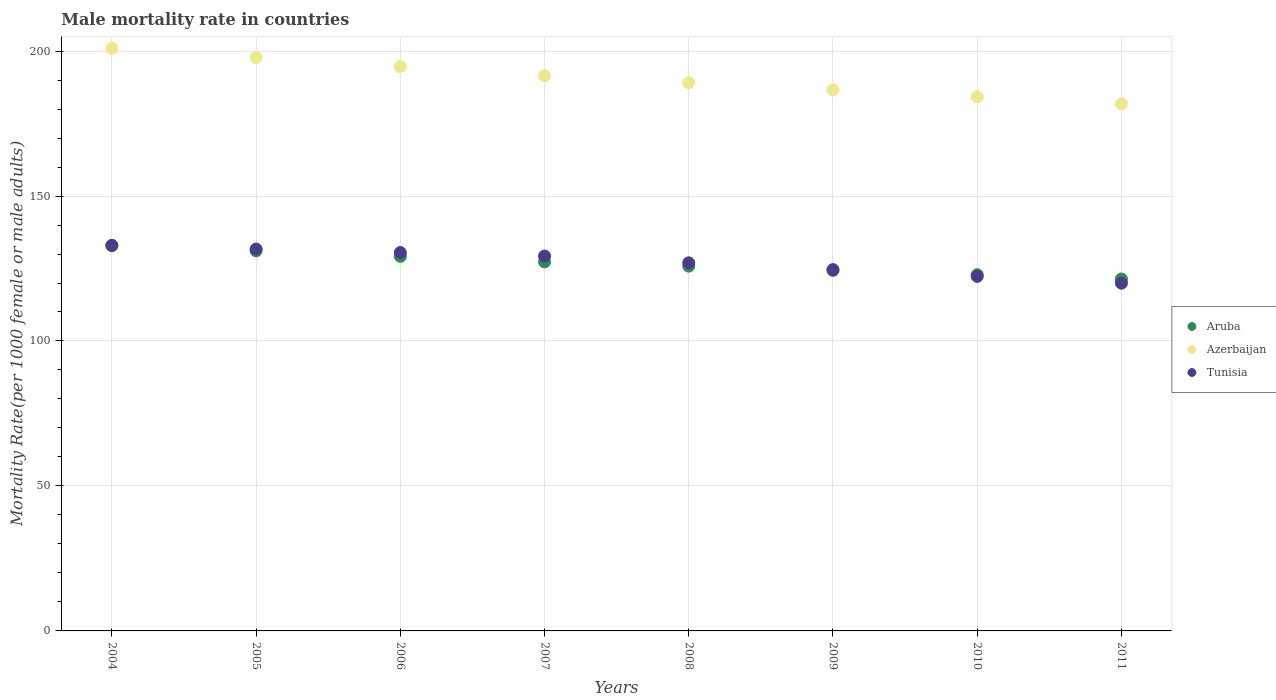Is the number of dotlines equal to the number of legend labels?
Give a very brief answer. Yes. What is the male mortality rate in Tunisia in 2009?
Keep it short and to the point. 124.62. Across all years, what is the maximum male mortality rate in Tunisia?
Your answer should be very brief. 132.93. Across all years, what is the minimum male mortality rate in Tunisia?
Give a very brief answer. 119.94. In which year was the male mortality rate in Aruba maximum?
Your answer should be very brief. 2004. What is the total male mortality rate in Azerbaijan in the graph?
Offer a very short reply. 1526.63. What is the difference between the male mortality rate in Azerbaijan in 2005 and that in 2010?
Ensure brevity in your answer.  13.57. What is the difference between the male mortality rate in Tunisia in 2006 and the male mortality rate in Azerbaijan in 2004?
Ensure brevity in your answer.  -70.43. What is the average male mortality rate in Azerbaijan per year?
Your answer should be compact. 190.83. In the year 2004, what is the difference between the male mortality rate in Tunisia and male mortality rate in Aruba?
Give a very brief answer. -0.06. What is the ratio of the male mortality rate in Azerbaijan in 2008 to that in 2010?
Your answer should be very brief. 1.03. What is the difference between the highest and the second highest male mortality rate in Aruba?
Offer a terse response. 1.9. What is the difference between the highest and the lowest male mortality rate in Tunisia?
Offer a terse response. 12.99. Does the male mortality rate in Aruba monotonically increase over the years?
Offer a very short reply. No. Is the male mortality rate in Azerbaijan strictly greater than the male mortality rate in Aruba over the years?
Give a very brief answer. Yes. How many years are there in the graph?
Provide a succinct answer. 8. Are the values on the major ticks of Y-axis written in scientific E-notation?
Give a very brief answer. No. Does the graph contain any zero values?
Your response must be concise. No. Does the graph contain grids?
Give a very brief answer. Yes. Where does the legend appear in the graph?
Offer a very short reply. Center right. How many legend labels are there?
Ensure brevity in your answer.  3. What is the title of the graph?
Your answer should be compact. Male mortality rate in countries. What is the label or title of the X-axis?
Your answer should be very brief. Years. What is the label or title of the Y-axis?
Make the answer very short. Mortality Rate(per 1000 female or male adults). What is the Mortality Rate(per 1000 female or male adults) of Aruba in 2004?
Give a very brief answer. 132.99. What is the Mortality Rate(per 1000 female or male adults) in Azerbaijan in 2004?
Ensure brevity in your answer.  200.95. What is the Mortality Rate(per 1000 female or male adults) of Tunisia in 2004?
Give a very brief answer. 132.93. What is the Mortality Rate(per 1000 female or male adults) in Aruba in 2005?
Keep it short and to the point. 131.09. What is the Mortality Rate(per 1000 female or male adults) of Azerbaijan in 2005?
Offer a very short reply. 197.8. What is the Mortality Rate(per 1000 female or male adults) in Tunisia in 2005?
Keep it short and to the point. 131.72. What is the Mortality Rate(per 1000 female or male adults) of Aruba in 2006?
Offer a terse response. 129.19. What is the Mortality Rate(per 1000 female or male adults) in Azerbaijan in 2006?
Make the answer very short. 194.65. What is the Mortality Rate(per 1000 female or male adults) in Tunisia in 2006?
Your answer should be compact. 130.51. What is the Mortality Rate(per 1000 female or male adults) in Aruba in 2007?
Provide a short and direct response. 127.29. What is the Mortality Rate(per 1000 female or male adults) in Azerbaijan in 2007?
Your answer should be compact. 191.5. What is the Mortality Rate(per 1000 female or male adults) of Tunisia in 2007?
Provide a succinct answer. 129.3. What is the Mortality Rate(per 1000 female or male adults) in Aruba in 2008?
Ensure brevity in your answer.  125.81. What is the Mortality Rate(per 1000 female or male adults) of Azerbaijan in 2008?
Keep it short and to the point. 189.07. What is the Mortality Rate(per 1000 female or male adults) of Tunisia in 2008?
Offer a terse response. 126.96. What is the Mortality Rate(per 1000 female or male adults) in Aruba in 2009?
Your answer should be compact. 124.33. What is the Mortality Rate(per 1000 female or male adults) in Azerbaijan in 2009?
Your answer should be compact. 186.65. What is the Mortality Rate(per 1000 female or male adults) in Tunisia in 2009?
Provide a succinct answer. 124.62. What is the Mortality Rate(per 1000 female or male adults) in Aruba in 2010?
Provide a succinct answer. 122.86. What is the Mortality Rate(per 1000 female or male adults) in Azerbaijan in 2010?
Give a very brief answer. 184.22. What is the Mortality Rate(per 1000 female or male adults) of Tunisia in 2010?
Make the answer very short. 122.28. What is the Mortality Rate(per 1000 female or male adults) of Aruba in 2011?
Ensure brevity in your answer.  121.38. What is the Mortality Rate(per 1000 female or male adults) of Azerbaijan in 2011?
Offer a very short reply. 181.8. What is the Mortality Rate(per 1000 female or male adults) of Tunisia in 2011?
Keep it short and to the point. 119.94. Across all years, what is the maximum Mortality Rate(per 1000 female or male adults) of Aruba?
Offer a very short reply. 132.99. Across all years, what is the maximum Mortality Rate(per 1000 female or male adults) of Azerbaijan?
Make the answer very short. 200.95. Across all years, what is the maximum Mortality Rate(per 1000 female or male adults) of Tunisia?
Provide a succinct answer. 132.93. Across all years, what is the minimum Mortality Rate(per 1000 female or male adults) of Aruba?
Your response must be concise. 121.38. Across all years, what is the minimum Mortality Rate(per 1000 female or male adults) in Azerbaijan?
Your answer should be compact. 181.8. Across all years, what is the minimum Mortality Rate(per 1000 female or male adults) of Tunisia?
Give a very brief answer. 119.94. What is the total Mortality Rate(per 1000 female or male adults) in Aruba in the graph?
Give a very brief answer. 1014.94. What is the total Mortality Rate(per 1000 female or male adults) in Azerbaijan in the graph?
Offer a very short reply. 1526.63. What is the total Mortality Rate(per 1000 female or male adults) of Tunisia in the graph?
Give a very brief answer. 1018.26. What is the difference between the Mortality Rate(per 1000 female or male adults) of Aruba in 2004 and that in 2005?
Your response must be concise. 1.9. What is the difference between the Mortality Rate(per 1000 female or male adults) of Azerbaijan in 2004 and that in 2005?
Your answer should be compact. 3.15. What is the difference between the Mortality Rate(per 1000 female or male adults) of Tunisia in 2004 and that in 2005?
Your answer should be very brief. 1.21. What is the difference between the Mortality Rate(per 1000 female or male adults) of Aruba in 2004 and that in 2006?
Give a very brief answer. 3.8. What is the difference between the Mortality Rate(per 1000 female or male adults) of Azerbaijan in 2004 and that in 2006?
Your answer should be very brief. 6.3. What is the difference between the Mortality Rate(per 1000 female or male adults) of Tunisia in 2004 and that in 2006?
Ensure brevity in your answer.  2.42. What is the difference between the Mortality Rate(per 1000 female or male adults) of Aruba in 2004 and that in 2007?
Keep it short and to the point. 5.7. What is the difference between the Mortality Rate(per 1000 female or male adults) of Azerbaijan in 2004 and that in 2007?
Your answer should be compact. 9.45. What is the difference between the Mortality Rate(per 1000 female or male adults) of Tunisia in 2004 and that in 2007?
Offer a terse response. 3.62. What is the difference between the Mortality Rate(per 1000 female or male adults) in Aruba in 2004 and that in 2008?
Provide a succinct answer. 7.18. What is the difference between the Mortality Rate(per 1000 female or male adults) in Azerbaijan in 2004 and that in 2008?
Offer a very short reply. 11.87. What is the difference between the Mortality Rate(per 1000 female or male adults) in Tunisia in 2004 and that in 2008?
Provide a succinct answer. 5.96. What is the difference between the Mortality Rate(per 1000 female or male adults) of Aruba in 2004 and that in 2009?
Your answer should be very brief. 8.65. What is the difference between the Mortality Rate(per 1000 female or male adults) of Azerbaijan in 2004 and that in 2009?
Provide a short and direct response. 14.3. What is the difference between the Mortality Rate(per 1000 female or male adults) of Tunisia in 2004 and that in 2009?
Your answer should be compact. 8.31. What is the difference between the Mortality Rate(per 1000 female or male adults) of Aruba in 2004 and that in 2010?
Offer a very short reply. 10.13. What is the difference between the Mortality Rate(per 1000 female or male adults) of Azerbaijan in 2004 and that in 2010?
Provide a short and direct response. 16.72. What is the difference between the Mortality Rate(per 1000 female or male adults) of Tunisia in 2004 and that in 2010?
Provide a succinct answer. 10.65. What is the difference between the Mortality Rate(per 1000 female or male adults) of Aruba in 2004 and that in 2011?
Offer a terse response. 11.61. What is the difference between the Mortality Rate(per 1000 female or male adults) in Azerbaijan in 2004 and that in 2011?
Your response must be concise. 19.15. What is the difference between the Mortality Rate(per 1000 female or male adults) of Tunisia in 2004 and that in 2011?
Your answer should be very brief. 12.99. What is the difference between the Mortality Rate(per 1000 female or male adults) of Aruba in 2005 and that in 2006?
Give a very brief answer. 1.9. What is the difference between the Mortality Rate(per 1000 female or male adults) in Azerbaijan in 2005 and that in 2006?
Offer a terse response. 3.15. What is the difference between the Mortality Rate(per 1000 female or male adults) in Tunisia in 2005 and that in 2006?
Give a very brief answer. 1.21. What is the difference between the Mortality Rate(per 1000 female or male adults) of Aruba in 2005 and that in 2007?
Offer a very short reply. 3.8. What is the difference between the Mortality Rate(per 1000 female or male adults) in Azerbaijan in 2005 and that in 2007?
Your answer should be very brief. 6.3. What is the difference between the Mortality Rate(per 1000 female or male adults) in Tunisia in 2005 and that in 2007?
Make the answer very short. 2.42. What is the difference between the Mortality Rate(per 1000 female or male adults) of Aruba in 2005 and that in 2008?
Your answer should be very brief. 5.28. What is the difference between the Mortality Rate(per 1000 female or male adults) in Azerbaijan in 2005 and that in 2008?
Ensure brevity in your answer.  8.72. What is the difference between the Mortality Rate(per 1000 female or male adults) in Tunisia in 2005 and that in 2008?
Give a very brief answer. 4.76. What is the difference between the Mortality Rate(per 1000 female or male adults) of Aruba in 2005 and that in 2009?
Your answer should be compact. 6.75. What is the difference between the Mortality Rate(per 1000 female or male adults) of Azerbaijan in 2005 and that in 2009?
Keep it short and to the point. 11.15. What is the difference between the Mortality Rate(per 1000 female or male adults) in Tunisia in 2005 and that in 2009?
Make the answer very short. 7.1. What is the difference between the Mortality Rate(per 1000 female or male adults) in Aruba in 2005 and that in 2010?
Your answer should be very brief. 8.23. What is the difference between the Mortality Rate(per 1000 female or male adults) in Azerbaijan in 2005 and that in 2010?
Your answer should be compact. 13.57. What is the difference between the Mortality Rate(per 1000 female or male adults) in Tunisia in 2005 and that in 2010?
Offer a terse response. 9.44. What is the difference between the Mortality Rate(per 1000 female or male adults) of Aruba in 2005 and that in 2011?
Provide a short and direct response. 9.71. What is the difference between the Mortality Rate(per 1000 female or male adults) of Azerbaijan in 2005 and that in 2011?
Make the answer very short. 16. What is the difference between the Mortality Rate(per 1000 female or male adults) of Tunisia in 2005 and that in 2011?
Give a very brief answer. 11.78. What is the difference between the Mortality Rate(per 1000 female or male adults) in Aruba in 2006 and that in 2007?
Provide a short and direct response. 1.9. What is the difference between the Mortality Rate(per 1000 female or male adults) of Azerbaijan in 2006 and that in 2007?
Keep it short and to the point. 3.15. What is the difference between the Mortality Rate(per 1000 female or male adults) of Tunisia in 2006 and that in 2007?
Make the answer very short. 1.21. What is the difference between the Mortality Rate(per 1000 female or male adults) of Aruba in 2006 and that in 2008?
Give a very brief answer. 3.38. What is the difference between the Mortality Rate(per 1000 female or male adults) of Azerbaijan in 2006 and that in 2008?
Give a very brief answer. 5.57. What is the difference between the Mortality Rate(per 1000 female or male adults) in Tunisia in 2006 and that in 2008?
Your answer should be very brief. 3.55. What is the difference between the Mortality Rate(per 1000 female or male adults) in Aruba in 2006 and that in 2009?
Give a very brief answer. 4.85. What is the difference between the Mortality Rate(per 1000 female or male adults) of Azerbaijan in 2006 and that in 2009?
Your response must be concise. 8. What is the difference between the Mortality Rate(per 1000 female or male adults) of Tunisia in 2006 and that in 2009?
Offer a very short reply. 5.89. What is the difference between the Mortality Rate(per 1000 female or male adults) of Aruba in 2006 and that in 2010?
Ensure brevity in your answer.  6.33. What is the difference between the Mortality Rate(per 1000 female or male adults) in Azerbaijan in 2006 and that in 2010?
Offer a very short reply. 10.42. What is the difference between the Mortality Rate(per 1000 female or male adults) in Tunisia in 2006 and that in 2010?
Make the answer very short. 8.23. What is the difference between the Mortality Rate(per 1000 female or male adults) of Aruba in 2006 and that in 2011?
Your response must be concise. 7.8. What is the difference between the Mortality Rate(per 1000 female or male adults) of Azerbaijan in 2006 and that in 2011?
Give a very brief answer. 12.85. What is the difference between the Mortality Rate(per 1000 female or male adults) of Tunisia in 2006 and that in 2011?
Offer a very short reply. 10.57. What is the difference between the Mortality Rate(per 1000 female or male adults) of Aruba in 2007 and that in 2008?
Provide a short and direct response. 1.48. What is the difference between the Mortality Rate(per 1000 female or male adults) in Azerbaijan in 2007 and that in 2008?
Keep it short and to the point. 2.43. What is the difference between the Mortality Rate(per 1000 female or male adults) in Tunisia in 2007 and that in 2008?
Your answer should be compact. 2.34. What is the difference between the Mortality Rate(per 1000 female or male adults) in Aruba in 2007 and that in 2009?
Give a very brief answer. 2.95. What is the difference between the Mortality Rate(per 1000 female or male adults) of Azerbaijan in 2007 and that in 2009?
Ensure brevity in your answer.  4.85. What is the difference between the Mortality Rate(per 1000 female or male adults) of Tunisia in 2007 and that in 2009?
Your answer should be very brief. 4.68. What is the difference between the Mortality Rate(per 1000 female or male adults) in Aruba in 2007 and that in 2010?
Provide a succinct answer. 4.43. What is the difference between the Mortality Rate(per 1000 female or male adults) in Azerbaijan in 2007 and that in 2010?
Your answer should be very brief. 7.28. What is the difference between the Mortality Rate(per 1000 female or male adults) of Tunisia in 2007 and that in 2010?
Offer a terse response. 7.02. What is the difference between the Mortality Rate(per 1000 female or male adults) of Aruba in 2007 and that in 2011?
Make the answer very short. 5.9. What is the difference between the Mortality Rate(per 1000 female or male adults) in Azerbaijan in 2007 and that in 2011?
Make the answer very short. 9.7. What is the difference between the Mortality Rate(per 1000 female or male adults) of Tunisia in 2007 and that in 2011?
Keep it short and to the point. 9.37. What is the difference between the Mortality Rate(per 1000 female or male adults) of Aruba in 2008 and that in 2009?
Ensure brevity in your answer.  1.48. What is the difference between the Mortality Rate(per 1000 female or male adults) in Azerbaijan in 2008 and that in 2009?
Offer a very short reply. 2.43. What is the difference between the Mortality Rate(per 1000 female or male adults) of Tunisia in 2008 and that in 2009?
Provide a short and direct response. 2.34. What is the difference between the Mortality Rate(per 1000 female or male adults) in Aruba in 2008 and that in 2010?
Your answer should be very brief. 2.95. What is the difference between the Mortality Rate(per 1000 female or male adults) in Azerbaijan in 2008 and that in 2010?
Your answer should be very brief. 4.85. What is the difference between the Mortality Rate(per 1000 female or male adults) in Tunisia in 2008 and that in 2010?
Your answer should be very brief. 4.68. What is the difference between the Mortality Rate(per 1000 female or male adults) in Aruba in 2008 and that in 2011?
Your response must be concise. 4.43. What is the difference between the Mortality Rate(per 1000 female or male adults) of Azerbaijan in 2008 and that in 2011?
Keep it short and to the point. 7.28. What is the difference between the Mortality Rate(per 1000 female or male adults) in Tunisia in 2008 and that in 2011?
Offer a terse response. 7.02. What is the difference between the Mortality Rate(per 1000 female or male adults) in Aruba in 2009 and that in 2010?
Give a very brief answer. 1.48. What is the difference between the Mortality Rate(per 1000 female or male adults) of Azerbaijan in 2009 and that in 2010?
Offer a very short reply. 2.43. What is the difference between the Mortality Rate(per 1000 female or male adults) in Tunisia in 2009 and that in 2010?
Offer a very short reply. 2.34. What is the difference between the Mortality Rate(per 1000 female or male adults) of Aruba in 2009 and that in 2011?
Give a very brief answer. 2.95. What is the difference between the Mortality Rate(per 1000 female or male adults) in Azerbaijan in 2009 and that in 2011?
Your response must be concise. 4.85. What is the difference between the Mortality Rate(per 1000 female or male adults) of Tunisia in 2009 and that in 2011?
Give a very brief answer. 4.68. What is the difference between the Mortality Rate(per 1000 female or male adults) in Aruba in 2010 and that in 2011?
Provide a succinct answer. 1.48. What is the difference between the Mortality Rate(per 1000 female or male adults) of Azerbaijan in 2010 and that in 2011?
Your answer should be very brief. 2.43. What is the difference between the Mortality Rate(per 1000 female or male adults) in Tunisia in 2010 and that in 2011?
Your response must be concise. 2.34. What is the difference between the Mortality Rate(per 1000 female or male adults) of Aruba in 2004 and the Mortality Rate(per 1000 female or male adults) of Azerbaijan in 2005?
Provide a short and direct response. -64.81. What is the difference between the Mortality Rate(per 1000 female or male adults) of Aruba in 2004 and the Mortality Rate(per 1000 female or male adults) of Tunisia in 2005?
Keep it short and to the point. 1.27. What is the difference between the Mortality Rate(per 1000 female or male adults) in Azerbaijan in 2004 and the Mortality Rate(per 1000 female or male adults) in Tunisia in 2005?
Give a very brief answer. 69.23. What is the difference between the Mortality Rate(per 1000 female or male adults) in Aruba in 2004 and the Mortality Rate(per 1000 female or male adults) in Azerbaijan in 2006?
Make the answer very short. -61.66. What is the difference between the Mortality Rate(per 1000 female or male adults) of Aruba in 2004 and the Mortality Rate(per 1000 female or male adults) of Tunisia in 2006?
Make the answer very short. 2.48. What is the difference between the Mortality Rate(per 1000 female or male adults) in Azerbaijan in 2004 and the Mortality Rate(per 1000 female or male adults) in Tunisia in 2006?
Your response must be concise. 70.43. What is the difference between the Mortality Rate(per 1000 female or male adults) in Aruba in 2004 and the Mortality Rate(per 1000 female or male adults) in Azerbaijan in 2007?
Keep it short and to the point. -58.51. What is the difference between the Mortality Rate(per 1000 female or male adults) of Aruba in 2004 and the Mortality Rate(per 1000 female or male adults) of Tunisia in 2007?
Your answer should be very brief. 3.69. What is the difference between the Mortality Rate(per 1000 female or male adults) in Azerbaijan in 2004 and the Mortality Rate(per 1000 female or male adults) in Tunisia in 2007?
Make the answer very short. 71.64. What is the difference between the Mortality Rate(per 1000 female or male adults) of Aruba in 2004 and the Mortality Rate(per 1000 female or male adults) of Azerbaijan in 2008?
Give a very brief answer. -56.08. What is the difference between the Mortality Rate(per 1000 female or male adults) of Aruba in 2004 and the Mortality Rate(per 1000 female or male adults) of Tunisia in 2008?
Provide a succinct answer. 6.03. What is the difference between the Mortality Rate(per 1000 female or male adults) in Azerbaijan in 2004 and the Mortality Rate(per 1000 female or male adults) in Tunisia in 2008?
Your response must be concise. 73.98. What is the difference between the Mortality Rate(per 1000 female or male adults) in Aruba in 2004 and the Mortality Rate(per 1000 female or male adults) in Azerbaijan in 2009?
Give a very brief answer. -53.66. What is the difference between the Mortality Rate(per 1000 female or male adults) in Aruba in 2004 and the Mortality Rate(per 1000 female or male adults) in Tunisia in 2009?
Offer a very short reply. 8.37. What is the difference between the Mortality Rate(per 1000 female or male adults) in Azerbaijan in 2004 and the Mortality Rate(per 1000 female or male adults) in Tunisia in 2009?
Provide a succinct answer. 76.33. What is the difference between the Mortality Rate(per 1000 female or male adults) in Aruba in 2004 and the Mortality Rate(per 1000 female or male adults) in Azerbaijan in 2010?
Make the answer very short. -51.23. What is the difference between the Mortality Rate(per 1000 female or male adults) of Aruba in 2004 and the Mortality Rate(per 1000 female or male adults) of Tunisia in 2010?
Provide a succinct answer. 10.71. What is the difference between the Mortality Rate(per 1000 female or male adults) of Azerbaijan in 2004 and the Mortality Rate(per 1000 female or male adults) of Tunisia in 2010?
Your answer should be very brief. 78.67. What is the difference between the Mortality Rate(per 1000 female or male adults) of Aruba in 2004 and the Mortality Rate(per 1000 female or male adults) of Azerbaijan in 2011?
Give a very brief answer. -48.81. What is the difference between the Mortality Rate(per 1000 female or male adults) in Aruba in 2004 and the Mortality Rate(per 1000 female or male adults) in Tunisia in 2011?
Your answer should be very brief. 13.05. What is the difference between the Mortality Rate(per 1000 female or male adults) in Azerbaijan in 2004 and the Mortality Rate(per 1000 female or male adults) in Tunisia in 2011?
Your answer should be compact. 81.01. What is the difference between the Mortality Rate(per 1000 female or male adults) of Aruba in 2005 and the Mortality Rate(per 1000 female or male adults) of Azerbaijan in 2006?
Keep it short and to the point. -63.56. What is the difference between the Mortality Rate(per 1000 female or male adults) of Aruba in 2005 and the Mortality Rate(per 1000 female or male adults) of Tunisia in 2006?
Offer a very short reply. 0.58. What is the difference between the Mortality Rate(per 1000 female or male adults) in Azerbaijan in 2005 and the Mortality Rate(per 1000 female or male adults) in Tunisia in 2006?
Ensure brevity in your answer.  67.29. What is the difference between the Mortality Rate(per 1000 female or male adults) in Aruba in 2005 and the Mortality Rate(per 1000 female or male adults) in Azerbaijan in 2007?
Provide a succinct answer. -60.41. What is the difference between the Mortality Rate(per 1000 female or male adults) in Aruba in 2005 and the Mortality Rate(per 1000 female or male adults) in Tunisia in 2007?
Your answer should be very brief. 1.78. What is the difference between the Mortality Rate(per 1000 female or male adults) of Azerbaijan in 2005 and the Mortality Rate(per 1000 female or male adults) of Tunisia in 2007?
Ensure brevity in your answer.  68.49. What is the difference between the Mortality Rate(per 1000 female or male adults) of Aruba in 2005 and the Mortality Rate(per 1000 female or male adults) of Azerbaijan in 2008?
Your answer should be compact. -57.98. What is the difference between the Mortality Rate(per 1000 female or male adults) in Aruba in 2005 and the Mortality Rate(per 1000 female or male adults) in Tunisia in 2008?
Your response must be concise. 4.13. What is the difference between the Mortality Rate(per 1000 female or male adults) of Azerbaijan in 2005 and the Mortality Rate(per 1000 female or male adults) of Tunisia in 2008?
Give a very brief answer. 70.83. What is the difference between the Mortality Rate(per 1000 female or male adults) of Aruba in 2005 and the Mortality Rate(per 1000 female or male adults) of Azerbaijan in 2009?
Your answer should be compact. -55.56. What is the difference between the Mortality Rate(per 1000 female or male adults) of Aruba in 2005 and the Mortality Rate(per 1000 female or male adults) of Tunisia in 2009?
Make the answer very short. 6.47. What is the difference between the Mortality Rate(per 1000 female or male adults) in Azerbaijan in 2005 and the Mortality Rate(per 1000 female or male adults) in Tunisia in 2009?
Provide a short and direct response. 73.18. What is the difference between the Mortality Rate(per 1000 female or male adults) of Aruba in 2005 and the Mortality Rate(per 1000 female or male adults) of Azerbaijan in 2010?
Make the answer very short. -53.13. What is the difference between the Mortality Rate(per 1000 female or male adults) in Aruba in 2005 and the Mortality Rate(per 1000 female or male adults) in Tunisia in 2010?
Your answer should be very brief. 8.81. What is the difference between the Mortality Rate(per 1000 female or male adults) in Azerbaijan in 2005 and the Mortality Rate(per 1000 female or male adults) in Tunisia in 2010?
Provide a succinct answer. 75.52. What is the difference between the Mortality Rate(per 1000 female or male adults) in Aruba in 2005 and the Mortality Rate(per 1000 female or male adults) in Azerbaijan in 2011?
Your response must be concise. -50.71. What is the difference between the Mortality Rate(per 1000 female or male adults) of Aruba in 2005 and the Mortality Rate(per 1000 female or male adults) of Tunisia in 2011?
Offer a terse response. 11.15. What is the difference between the Mortality Rate(per 1000 female or male adults) in Azerbaijan in 2005 and the Mortality Rate(per 1000 female or male adults) in Tunisia in 2011?
Give a very brief answer. 77.86. What is the difference between the Mortality Rate(per 1000 female or male adults) in Aruba in 2006 and the Mortality Rate(per 1000 female or male adults) in Azerbaijan in 2007?
Offer a terse response. -62.31. What is the difference between the Mortality Rate(per 1000 female or male adults) in Aruba in 2006 and the Mortality Rate(per 1000 female or male adults) in Tunisia in 2007?
Provide a succinct answer. -0.12. What is the difference between the Mortality Rate(per 1000 female or male adults) in Azerbaijan in 2006 and the Mortality Rate(per 1000 female or male adults) in Tunisia in 2007?
Your answer should be very brief. 65.34. What is the difference between the Mortality Rate(per 1000 female or male adults) in Aruba in 2006 and the Mortality Rate(per 1000 female or male adults) in Azerbaijan in 2008?
Offer a very short reply. -59.88. What is the difference between the Mortality Rate(per 1000 female or male adults) of Aruba in 2006 and the Mortality Rate(per 1000 female or male adults) of Tunisia in 2008?
Give a very brief answer. 2.23. What is the difference between the Mortality Rate(per 1000 female or male adults) of Azerbaijan in 2006 and the Mortality Rate(per 1000 female or male adults) of Tunisia in 2008?
Keep it short and to the point. 67.69. What is the difference between the Mortality Rate(per 1000 female or male adults) of Aruba in 2006 and the Mortality Rate(per 1000 female or male adults) of Azerbaijan in 2009?
Offer a terse response. -57.46. What is the difference between the Mortality Rate(per 1000 female or male adults) of Aruba in 2006 and the Mortality Rate(per 1000 female or male adults) of Tunisia in 2009?
Make the answer very short. 4.57. What is the difference between the Mortality Rate(per 1000 female or male adults) of Azerbaijan in 2006 and the Mortality Rate(per 1000 female or male adults) of Tunisia in 2009?
Your answer should be very brief. 70.03. What is the difference between the Mortality Rate(per 1000 female or male adults) in Aruba in 2006 and the Mortality Rate(per 1000 female or male adults) in Azerbaijan in 2010?
Provide a succinct answer. -55.03. What is the difference between the Mortality Rate(per 1000 female or male adults) in Aruba in 2006 and the Mortality Rate(per 1000 female or male adults) in Tunisia in 2010?
Make the answer very short. 6.91. What is the difference between the Mortality Rate(per 1000 female or male adults) in Azerbaijan in 2006 and the Mortality Rate(per 1000 female or male adults) in Tunisia in 2010?
Your answer should be compact. 72.37. What is the difference between the Mortality Rate(per 1000 female or male adults) of Aruba in 2006 and the Mortality Rate(per 1000 female or male adults) of Azerbaijan in 2011?
Make the answer very short. -52.61. What is the difference between the Mortality Rate(per 1000 female or male adults) of Aruba in 2006 and the Mortality Rate(per 1000 female or male adults) of Tunisia in 2011?
Give a very brief answer. 9.25. What is the difference between the Mortality Rate(per 1000 female or male adults) in Azerbaijan in 2006 and the Mortality Rate(per 1000 female or male adults) in Tunisia in 2011?
Your answer should be compact. 74.71. What is the difference between the Mortality Rate(per 1000 female or male adults) in Aruba in 2007 and the Mortality Rate(per 1000 female or male adults) in Azerbaijan in 2008?
Ensure brevity in your answer.  -61.79. What is the difference between the Mortality Rate(per 1000 female or male adults) of Aruba in 2007 and the Mortality Rate(per 1000 female or male adults) of Tunisia in 2008?
Your answer should be very brief. 0.33. What is the difference between the Mortality Rate(per 1000 female or male adults) of Azerbaijan in 2007 and the Mortality Rate(per 1000 female or male adults) of Tunisia in 2008?
Your answer should be compact. 64.54. What is the difference between the Mortality Rate(per 1000 female or male adults) of Aruba in 2007 and the Mortality Rate(per 1000 female or male adults) of Azerbaijan in 2009?
Your answer should be compact. -59.36. What is the difference between the Mortality Rate(per 1000 female or male adults) in Aruba in 2007 and the Mortality Rate(per 1000 female or male adults) in Tunisia in 2009?
Keep it short and to the point. 2.67. What is the difference between the Mortality Rate(per 1000 female or male adults) in Azerbaijan in 2007 and the Mortality Rate(per 1000 female or male adults) in Tunisia in 2009?
Your response must be concise. 66.88. What is the difference between the Mortality Rate(per 1000 female or male adults) of Aruba in 2007 and the Mortality Rate(per 1000 female or male adults) of Azerbaijan in 2010?
Give a very brief answer. -56.94. What is the difference between the Mortality Rate(per 1000 female or male adults) in Aruba in 2007 and the Mortality Rate(per 1000 female or male adults) in Tunisia in 2010?
Your answer should be very brief. 5.01. What is the difference between the Mortality Rate(per 1000 female or male adults) in Azerbaijan in 2007 and the Mortality Rate(per 1000 female or male adults) in Tunisia in 2010?
Offer a terse response. 69.22. What is the difference between the Mortality Rate(per 1000 female or male adults) of Aruba in 2007 and the Mortality Rate(per 1000 female or male adults) of Azerbaijan in 2011?
Provide a short and direct response. -54.51. What is the difference between the Mortality Rate(per 1000 female or male adults) in Aruba in 2007 and the Mortality Rate(per 1000 female or male adults) in Tunisia in 2011?
Your response must be concise. 7.35. What is the difference between the Mortality Rate(per 1000 female or male adults) in Azerbaijan in 2007 and the Mortality Rate(per 1000 female or male adults) in Tunisia in 2011?
Ensure brevity in your answer.  71.56. What is the difference between the Mortality Rate(per 1000 female or male adults) of Aruba in 2008 and the Mortality Rate(per 1000 female or male adults) of Azerbaijan in 2009?
Ensure brevity in your answer.  -60.84. What is the difference between the Mortality Rate(per 1000 female or male adults) in Aruba in 2008 and the Mortality Rate(per 1000 female or male adults) in Tunisia in 2009?
Your response must be concise. 1.19. What is the difference between the Mortality Rate(per 1000 female or male adults) in Azerbaijan in 2008 and the Mortality Rate(per 1000 female or male adults) in Tunisia in 2009?
Your answer should be compact. 64.45. What is the difference between the Mortality Rate(per 1000 female or male adults) in Aruba in 2008 and the Mortality Rate(per 1000 female or male adults) in Azerbaijan in 2010?
Your response must be concise. -58.41. What is the difference between the Mortality Rate(per 1000 female or male adults) of Aruba in 2008 and the Mortality Rate(per 1000 female or male adults) of Tunisia in 2010?
Provide a succinct answer. 3.53. What is the difference between the Mortality Rate(per 1000 female or male adults) of Azerbaijan in 2008 and the Mortality Rate(per 1000 female or male adults) of Tunisia in 2010?
Give a very brief answer. 66.79. What is the difference between the Mortality Rate(per 1000 female or male adults) of Aruba in 2008 and the Mortality Rate(per 1000 female or male adults) of Azerbaijan in 2011?
Your answer should be very brief. -55.99. What is the difference between the Mortality Rate(per 1000 female or male adults) of Aruba in 2008 and the Mortality Rate(per 1000 female or male adults) of Tunisia in 2011?
Make the answer very short. 5.87. What is the difference between the Mortality Rate(per 1000 female or male adults) of Azerbaijan in 2008 and the Mortality Rate(per 1000 female or male adults) of Tunisia in 2011?
Provide a short and direct response. 69.14. What is the difference between the Mortality Rate(per 1000 female or male adults) in Aruba in 2009 and the Mortality Rate(per 1000 female or male adults) in Azerbaijan in 2010?
Keep it short and to the point. -59.89. What is the difference between the Mortality Rate(per 1000 female or male adults) in Aruba in 2009 and the Mortality Rate(per 1000 female or male adults) in Tunisia in 2010?
Give a very brief answer. 2.06. What is the difference between the Mortality Rate(per 1000 female or male adults) of Azerbaijan in 2009 and the Mortality Rate(per 1000 female or male adults) of Tunisia in 2010?
Offer a terse response. 64.37. What is the difference between the Mortality Rate(per 1000 female or male adults) in Aruba in 2009 and the Mortality Rate(per 1000 female or male adults) in Azerbaijan in 2011?
Provide a short and direct response. -57.46. What is the difference between the Mortality Rate(per 1000 female or male adults) of Aruba in 2009 and the Mortality Rate(per 1000 female or male adults) of Tunisia in 2011?
Your response must be concise. 4.4. What is the difference between the Mortality Rate(per 1000 female or male adults) of Azerbaijan in 2009 and the Mortality Rate(per 1000 female or male adults) of Tunisia in 2011?
Provide a short and direct response. 66.71. What is the difference between the Mortality Rate(per 1000 female or male adults) in Aruba in 2010 and the Mortality Rate(per 1000 female or male adults) in Azerbaijan in 2011?
Your answer should be very brief. -58.94. What is the difference between the Mortality Rate(per 1000 female or male adults) in Aruba in 2010 and the Mortality Rate(per 1000 female or male adults) in Tunisia in 2011?
Keep it short and to the point. 2.92. What is the difference between the Mortality Rate(per 1000 female or male adults) in Azerbaijan in 2010 and the Mortality Rate(per 1000 female or male adults) in Tunisia in 2011?
Your response must be concise. 64.28. What is the average Mortality Rate(per 1000 female or male adults) in Aruba per year?
Ensure brevity in your answer.  126.87. What is the average Mortality Rate(per 1000 female or male adults) in Azerbaijan per year?
Offer a very short reply. 190.83. What is the average Mortality Rate(per 1000 female or male adults) in Tunisia per year?
Keep it short and to the point. 127.28. In the year 2004, what is the difference between the Mortality Rate(per 1000 female or male adults) of Aruba and Mortality Rate(per 1000 female or male adults) of Azerbaijan?
Offer a very short reply. -67.96. In the year 2004, what is the difference between the Mortality Rate(per 1000 female or male adults) in Aruba and Mortality Rate(per 1000 female or male adults) in Tunisia?
Make the answer very short. 0.06. In the year 2004, what is the difference between the Mortality Rate(per 1000 female or male adults) in Azerbaijan and Mortality Rate(per 1000 female or male adults) in Tunisia?
Ensure brevity in your answer.  68.02. In the year 2005, what is the difference between the Mortality Rate(per 1000 female or male adults) of Aruba and Mortality Rate(per 1000 female or male adults) of Azerbaijan?
Your response must be concise. -66.71. In the year 2005, what is the difference between the Mortality Rate(per 1000 female or male adults) of Aruba and Mortality Rate(per 1000 female or male adults) of Tunisia?
Make the answer very short. -0.63. In the year 2005, what is the difference between the Mortality Rate(per 1000 female or male adults) of Azerbaijan and Mortality Rate(per 1000 female or male adults) of Tunisia?
Your response must be concise. 66.08. In the year 2006, what is the difference between the Mortality Rate(per 1000 female or male adults) in Aruba and Mortality Rate(per 1000 female or male adults) in Azerbaijan?
Provide a succinct answer. -65.46. In the year 2006, what is the difference between the Mortality Rate(per 1000 female or male adults) in Aruba and Mortality Rate(per 1000 female or male adults) in Tunisia?
Provide a succinct answer. -1.32. In the year 2006, what is the difference between the Mortality Rate(per 1000 female or male adults) in Azerbaijan and Mortality Rate(per 1000 female or male adults) in Tunisia?
Ensure brevity in your answer.  64.14. In the year 2007, what is the difference between the Mortality Rate(per 1000 female or male adults) in Aruba and Mortality Rate(per 1000 female or male adults) in Azerbaijan?
Your answer should be very brief. -64.21. In the year 2007, what is the difference between the Mortality Rate(per 1000 female or male adults) in Aruba and Mortality Rate(per 1000 female or male adults) in Tunisia?
Provide a short and direct response. -2.02. In the year 2007, what is the difference between the Mortality Rate(per 1000 female or male adults) of Azerbaijan and Mortality Rate(per 1000 female or male adults) of Tunisia?
Offer a terse response. 62.2. In the year 2008, what is the difference between the Mortality Rate(per 1000 female or male adults) in Aruba and Mortality Rate(per 1000 female or male adults) in Azerbaijan?
Keep it short and to the point. -63.26. In the year 2008, what is the difference between the Mortality Rate(per 1000 female or male adults) in Aruba and Mortality Rate(per 1000 female or male adults) in Tunisia?
Make the answer very short. -1.15. In the year 2008, what is the difference between the Mortality Rate(per 1000 female or male adults) of Azerbaijan and Mortality Rate(per 1000 female or male adults) of Tunisia?
Give a very brief answer. 62.11. In the year 2009, what is the difference between the Mortality Rate(per 1000 female or male adults) of Aruba and Mortality Rate(per 1000 female or male adults) of Azerbaijan?
Your answer should be compact. -62.31. In the year 2009, what is the difference between the Mortality Rate(per 1000 female or male adults) of Aruba and Mortality Rate(per 1000 female or male adults) of Tunisia?
Keep it short and to the point. -0.29. In the year 2009, what is the difference between the Mortality Rate(per 1000 female or male adults) of Azerbaijan and Mortality Rate(per 1000 female or male adults) of Tunisia?
Provide a succinct answer. 62.03. In the year 2010, what is the difference between the Mortality Rate(per 1000 female or male adults) of Aruba and Mortality Rate(per 1000 female or male adults) of Azerbaijan?
Give a very brief answer. -61.36. In the year 2010, what is the difference between the Mortality Rate(per 1000 female or male adults) of Aruba and Mortality Rate(per 1000 female or male adults) of Tunisia?
Give a very brief answer. 0.58. In the year 2010, what is the difference between the Mortality Rate(per 1000 female or male adults) of Azerbaijan and Mortality Rate(per 1000 female or male adults) of Tunisia?
Your answer should be compact. 61.94. In the year 2011, what is the difference between the Mortality Rate(per 1000 female or male adults) in Aruba and Mortality Rate(per 1000 female or male adults) in Azerbaijan?
Ensure brevity in your answer.  -60.41. In the year 2011, what is the difference between the Mortality Rate(per 1000 female or male adults) of Aruba and Mortality Rate(per 1000 female or male adults) of Tunisia?
Your answer should be compact. 1.45. In the year 2011, what is the difference between the Mortality Rate(per 1000 female or male adults) in Azerbaijan and Mortality Rate(per 1000 female or male adults) in Tunisia?
Offer a very short reply. 61.86. What is the ratio of the Mortality Rate(per 1000 female or male adults) of Aruba in 2004 to that in 2005?
Provide a short and direct response. 1.01. What is the ratio of the Mortality Rate(per 1000 female or male adults) of Azerbaijan in 2004 to that in 2005?
Give a very brief answer. 1.02. What is the ratio of the Mortality Rate(per 1000 female or male adults) in Tunisia in 2004 to that in 2005?
Ensure brevity in your answer.  1.01. What is the ratio of the Mortality Rate(per 1000 female or male adults) in Aruba in 2004 to that in 2006?
Offer a very short reply. 1.03. What is the ratio of the Mortality Rate(per 1000 female or male adults) in Azerbaijan in 2004 to that in 2006?
Your response must be concise. 1.03. What is the ratio of the Mortality Rate(per 1000 female or male adults) in Tunisia in 2004 to that in 2006?
Your answer should be very brief. 1.02. What is the ratio of the Mortality Rate(per 1000 female or male adults) of Aruba in 2004 to that in 2007?
Keep it short and to the point. 1.04. What is the ratio of the Mortality Rate(per 1000 female or male adults) in Azerbaijan in 2004 to that in 2007?
Keep it short and to the point. 1.05. What is the ratio of the Mortality Rate(per 1000 female or male adults) in Tunisia in 2004 to that in 2007?
Offer a very short reply. 1.03. What is the ratio of the Mortality Rate(per 1000 female or male adults) of Aruba in 2004 to that in 2008?
Provide a succinct answer. 1.06. What is the ratio of the Mortality Rate(per 1000 female or male adults) in Azerbaijan in 2004 to that in 2008?
Give a very brief answer. 1.06. What is the ratio of the Mortality Rate(per 1000 female or male adults) in Tunisia in 2004 to that in 2008?
Provide a succinct answer. 1.05. What is the ratio of the Mortality Rate(per 1000 female or male adults) of Aruba in 2004 to that in 2009?
Provide a short and direct response. 1.07. What is the ratio of the Mortality Rate(per 1000 female or male adults) of Azerbaijan in 2004 to that in 2009?
Provide a succinct answer. 1.08. What is the ratio of the Mortality Rate(per 1000 female or male adults) in Tunisia in 2004 to that in 2009?
Make the answer very short. 1.07. What is the ratio of the Mortality Rate(per 1000 female or male adults) of Aruba in 2004 to that in 2010?
Your answer should be very brief. 1.08. What is the ratio of the Mortality Rate(per 1000 female or male adults) in Azerbaijan in 2004 to that in 2010?
Provide a short and direct response. 1.09. What is the ratio of the Mortality Rate(per 1000 female or male adults) in Tunisia in 2004 to that in 2010?
Your answer should be compact. 1.09. What is the ratio of the Mortality Rate(per 1000 female or male adults) of Aruba in 2004 to that in 2011?
Your answer should be compact. 1.1. What is the ratio of the Mortality Rate(per 1000 female or male adults) of Azerbaijan in 2004 to that in 2011?
Your answer should be compact. 1.11. What is the ratio of the Mortality Rate(per 1000 female or male adults) in Tunisia in 2004 to that in 2011?
Give a very brief answer. 1.11. What is the ratio of the Mortality Rate(per 1000 female or male adults) of Aruba in 2005 to that in 2006?
Ensure brevity in your answer.  1.01. What is the ratio of the Mortality Rate(per 1000 female or male adults) in Azerbaijan in 2005 to that in 2006?
Ensure brevity in your answer.  1.02. What is the ratio of the Mortality Rate(per 1000 female or male adults) in Tunisia in 2005 to that in 2006?
Offer a terse response. 1.01. What is the ratio of the Mortality Rate(per 1000 female or male adults) of Aruba in 2005 to that in 2007?
Ensure brevity in your answer.  1.03. What is the ratio of the Mortality Rate(per 1000 female or male adults) of Azerbaijan in 2005 to that in 2007?
Ensure brevity in your answer.  1.03. What is the ratio of the Mortality Rate(per 1000 female or male adults) in Tunisia in 2005 to that in 2007?
Make the answer very short. 1.02. What is the ratio of the Mortality Rate(per 1000 female or male adults) of Aruba in 2005 to that in 2008?
Your response must be concise. 1.04. What is the ratio of the Mortality Rate(per 1000 female or male adults) of Azerbaijan in 2005 to that in 2008?
Ensure brevity in your answer.  1.05. What is the ratio of the Mortality Rate(per 1000 female or male adults) in Tunisia in 2005 to that in 2008?
Ensure brevity in your answer.  1.04. What is the ratio of the Mortality Rate(per 1000 female or male adults) of Aruba in 2005 to that in 2009?
Provide a short and direct response. 1.05. What is the ratio of the Mortality Rate(per 1000 female or male adults) in Azerbaijan in 2005 to that in 2009?
Provide a short and direct response. 1.06. What is the ratio of the Mortality Rate(per 1000 female or male adults) in Tunisia in 2005 to that in 2009?
Keep it short and to the point. 1.06. What is the ratio of the Mortality Rate(per 1000 female or male adults) in Aruba in 2005 to that in 2010?
Make the answer very short. 1.07. What is the ratio of the Mortality Rate(per 1000 female or male adults) of Azerbaijan in 2005 to that in 2010?
Your response must be concise. 1.07. What is the ratio of the Mortality Rate(per 1000 female or male adults) of Tunisia in 2005 to that in 2010?
Provide a short and direct response. 1.08. What is the ratio of the Mortality Rate(per 1000 female or male adults) in Aruba in 2005 to that in 2011?
Keep it short and to the point. 1.08. What is the ratio of the Mortality Rate(per 1000 female or male adults) in Azerbaijan in 2005 to that in 2011?
Your answer should be compact. 1.09. What is the ratio of the Mortality Rate(per 1000 female or male adults) in Tunisia in 2005 to that in 2011?
Keep it short and to the point. 1.1. What is the ratio of the Mortality Rate(per 1000 female or male adults) in Aruba in 2006 to that in 2007?
Your answer should be very brief. 1.01. What is the ratio of the Mortality Rate(per 1000 female or male adults) of Azerbaijan in 2006 to that in 2007?
Your answer should be compact. 1.02. What is the ratio of the Mortality Rate(per 1000 female or male adults) in Tunisia in 2006 to that in 2007?
Offer a terse response. 1.01. What is the ratio of the Mortality Rate(per 1000 female or male adults) of Aruba in 2006 to that in 2008?
Your response must be concise. 1.03. What is the ratio of the Mortality Rate(per 1000 female or male adults) in Azerbaijan in 2006 to that in 2008?
Offer a very short reply. 1.03. What is the ratio of the Mortality Rate(per 1000 female or male adults) of Tunisia in 2006 to that in 2008?
Offer a very short reply. 1.03. What is the ratio of the Mortality Rate(per 1000 female or male adults) of Aruba in 2006 to that in 2009?
Your answer should be very brief. 1.04. What is the ratio of the Mortality Rate(per 1000 female or male adults) of Azerbaijan in 2006 to that in 2009?
Your answer should be very brief. 1.04. What is the ratio of the Mortality Rate(per 1000 female or male adults) of Tunisia in 2006 to that in 2009?
Your response must be concise. 1.05. What is the ratio of the Mortality Rate(per 1000 female or male adults) of Aruba in 2006 to that in 2010?
Ensure brevity in your answer.  1.05. What is the ratio of the Mortality Rate(per 1000 female or male adults) in Azerbaijan in 2006 to that in 2010?
Your response must be concise. 1.06. What is the ratio of the Mortality Rate(per 1000 female or male adults) in Tunisia in 2006 to that in 2010?
Make the answer very short. 1.07. What is the ratio of the Mortality Rate(per 1000 female or male adults) of Aruba in 2006 to that in 2011?
Your response must be concise. 1.06. What is the ratio of the Mortality Rate(per 1000 female or male adults) in Azerbaijan in 2006 to that in 2011?
Your answer should be very brief. 1.07. What is the ratio of the Mortality Rate(per 1000 female or male adults) in Tunisia in 2006 to that in 2011?
Offer a terse response. 1.09. What is the ratio of the Mortality Rate(per 1000 female or male adults) in Aruba in 2007 to that in 2008?
Your answer should be very brief. 1.01. What is the ratio of the Mortality Rate(per 1000 female or male adults) of Azerbaijan in 2007 to that in 2008?
Provide a short and direct response. 1.01. What is the ratio of the Mortality Rate(per 1000 female or male adults) of Tunisia in 2007 to that in 2008?
Ensure brevity in your answer.  1.02. What is the ratio of the Mortality Rate(per 1000 female or male adults) of Aruba in 2007 to that in 2009?
Your answer should be compact. 1.02. What is the ratio of the Mortality Rate(per 1000 female or male adults) in Tunisia in 2007 to that in 2009?
Your response must be concise. 1.04. What is the ratio of the Mortality Rate(per 1000 female or male adults) of Aruba in 2007 to that in 2010?
Give a very brief answer. 1.04. What is the ratio of the Mortality Rate(per 1000 female or male adults) of Azerbaijan in 2007 to that in 2010?
Ensure brevity in your answer.  1.04. What is the ratio of the Mortality Rate(per 1000 female or male adults) of Tunisia in 2007 to that in 2010?
Offer a very short reply. 1.06. What is the ratio of the Mortality Rate(per 1000 female or male adults) of Aruba in 2007 to that in 2011?
Provide a short and direct response. 1.05. What is the ratio of the Mortality Rate(per 1000 female or male adults) of Azerbaijan in 2007 to that in 2011?
Offer a very short reply. 1.05. What is the ratio of the Mortality Rate(per 1000 female or male adults) in Tunisia in 2007 to that in 2011?
Your answer should be compact. 1.08. What is the ratio of the Mortality Rate(per 1000 female or male adults) in Aruba in 2008 to that in 2009?
Your response must be concise. 1.01. What is the ratio of the Mortality Rate(per 1000 female or male adults) of Tunisia in 2008 to that in 2009?
Ensure brevity in your answer.  1.02. What is the ratio of the Mortality Rate(per 1000 female or male adults) in Aruba in 2008 to that in 2010?
Offer a very short reply. 1.02. What is the ratio of the Mortality Rate(per 1000 female or male adults) in Azerbaijan in 2008 to that in 2010?
Make the answer very short. 1.03. What is the ratio of the Mortality Rate(per 1000 female or male adults) in Tunisia in 2008 to that in 2010?
Provide a short and direct response. 1.04. What is the ratio of the Mortality Rate(per 1000 female or male adults) of Aruba in 2008 to that in 2011?
Offer a terse response. 1.04. What is the ratio of the Mortality Rate(per 1000 female or male adults) in Tunisia in 2008 to that in 2011?
Provide a short and direct response. 1.06. What is the ratio of the Mortality Rate(per 1000 female or male adults) of Azerbaijan in 2009 to that in 2010?
Offer a terse response. 1.01. What is the ratio of the Mortality Rate(per 1000 female or male adults) of Tunisia in 2009 to that in 2010?
Your answer should be compact. 1.02. What is the ratio of the Mortality Rate(per 1000 female or male adults) of Aruba in 2009 to that in 2011?
Offer a terse response. 1.02. What is the ratio of the Mortality Rate(per 1000 female or male adults) of Azerbaijan in 2009 to that in 2011?
Your response must be concise. 1.03. What is the ratio of the Mortality Rate(per 1000 female or male adults) of Tunisia in 2009 to that in 2011?
Offer a terse response. 1.04. What is the ratio of the Mortality Rate(per 1000 female or male adults) of Aruba in 2010 to that in 2011?
Your response must be concise. 1.01. What is the ratio of the Mortality Rate(per 1000 female or male adults) of Azerbaijan in 2010 to that in 2011?
Give a very brief answer. 1.01. What is the ratio of the Mortality Rate(per 1000 female or male adults) in Tunisia in 2010 to that in 2011?
Offer a terse response. 1.02. What is the difference between the highest and the second highest Mortality Rate(per 1000 female or male adults) in Aruba?
Offer a very short reply. 1.9. What is the difference between the highest and the second highest Mortality Rate(per 1000 female or male adults) in Azerbaijan?
Keep it short and to the point. 3.15. What is the difference between the highest and the second highest Mortality Rate(per 1000 female or male adults) in Tunisia?
Offer a very short reply. 1.21. What is the difference between the highest and the lowest Mortality Rate(per 1000 female or male adults) of Aruba?
Your answer should be compact. 11.61. What is the difference between the highest and the lowest Mortality Rate(per 1000 female or male adults) in Azerbaijan?
Give a very brief answer. 19.15. What is the difference between the highest and the lowest Mortality Rate(per 1000 female or male adults) in Tunisia?
Offer a terse response. 12.99. 